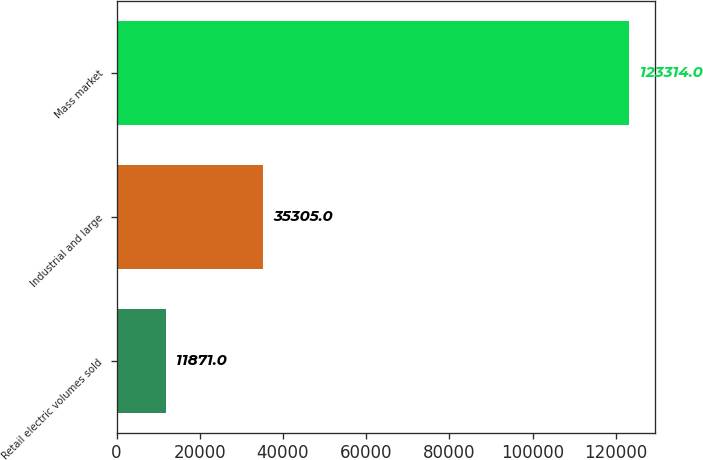Convert chart. <chart><loc_0><loc_0><loc_500><loc_500><bar_chart><fcel>Retail electric volumes sold<fcel>Industrial and large<fcel>Mass market<nl><fcel>11871<fcel>35305<fcel>123314<nl></chart> 